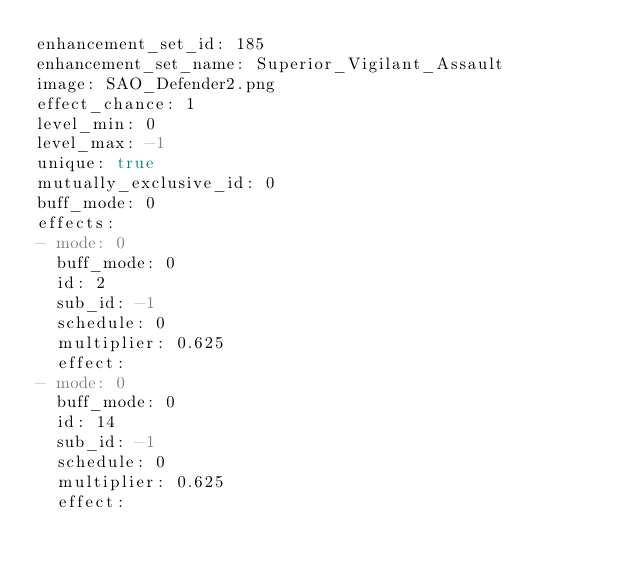Convert code to text. <code><loc_0><loc_0><loc_500><loc_500><_YAML_>enhancement_set_id: 185
enhancement_set_name: Superior_Vigilant_Assault
image: SAO_Defender2.png
effect_chance: 1
level_min: 0
level_max: -1
unique: true
mutually_exclusive_id: 0
buff_mode: 0
effects:
- mode: 0
  buff_mode: 0
  id: 2
  sub_id: -1
  schedule: 0
  multiplier: 0.625
  effect: 
- mode: 0
  buff_mode: 0
  id: 14
  sub_id: -1
  schedule: 0
  multiplier: 0.625
  effect: </code> 